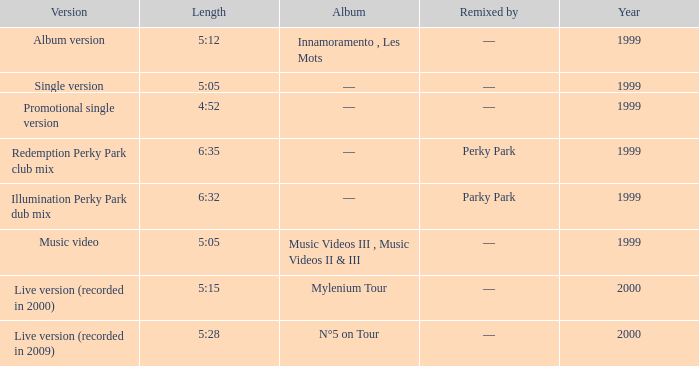What album is 5:15 long Live version (recorded in 2000). 